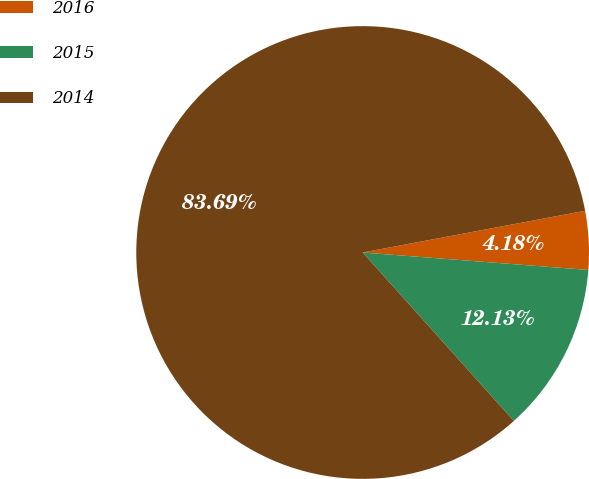Convert chart to OTSL. <chart><loc_0><loc_0><loc_500><loc_500><pie_chart><fcel>2016<fcel>2015<fcel>2014<nl><fcel>4.18%<fcel>12.13%<fcel>83.68%<nl></chart> 